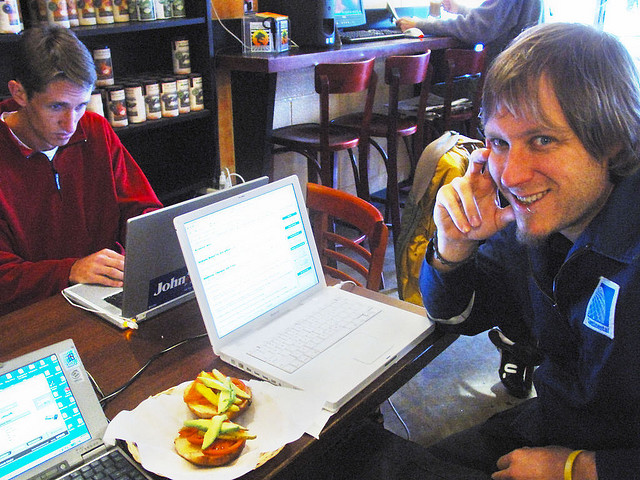What kind of activities might be suitable for this setting, based on what's in the image? Based on the image, suitable activities for this setting would include working on a laptop, possibly for remote work or academic studies, having a casual meeting, enjoying light meals such as sandwiches and coffee, or simply socializing with friends in an unhurried setting.  Let's say I wanted to hold a small business meeting here, would that seem appropriate? Given the relaxed atmosphere and the presence of others using laptops, it would probably be appropriate to hold a small, informal business meeting here. However, consider the noise level and privacy, as it seems like a public, open space which may not be ideal if the meeting requires confidentiality or quiet. 